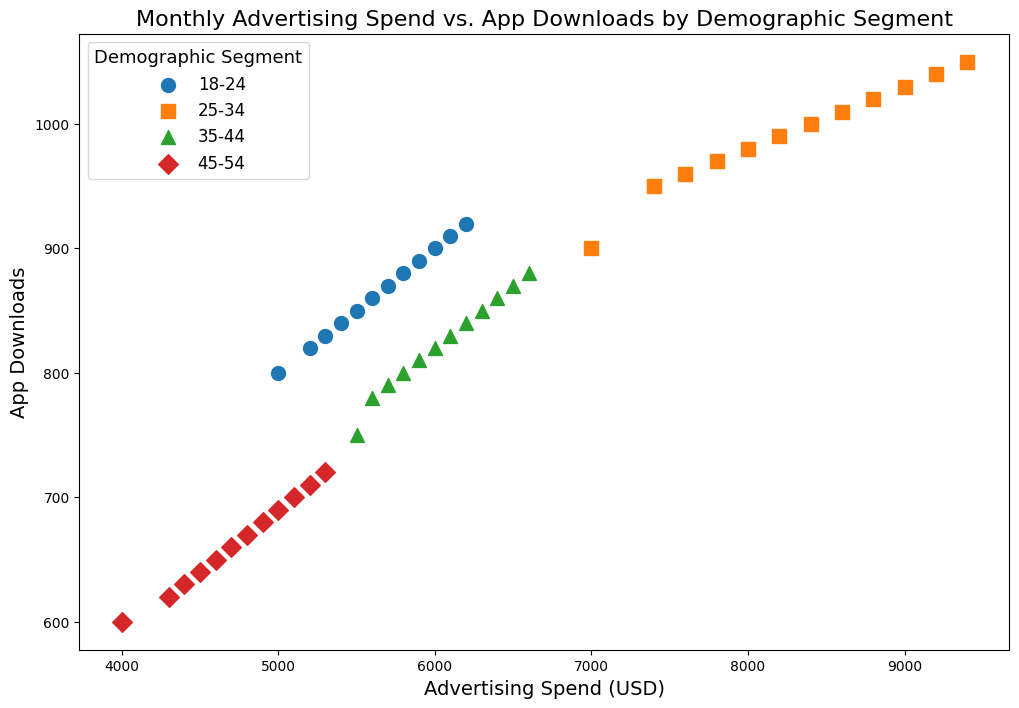What is the demographic segment with the highest app downloads in October 2023? Look at the points corresponding to October 2023 across different demographic segments. The segment '25-34' has the highest value of 1030 app downloads.
Answer: 25-34 Between the '18-24' and '45-54' segments, which had a higher app download rate in December 2023? Compare the app downloads for '18-24' and '45-54' segments in December 2023. The '18-24' segment had 920 downloads, while the '45-54' segment had 720 downloads.
Answer: 18-24 For the '35-44' demographic segment, which month had the highest number of app downloads? Locate the '35-44' segment across all months and identify the month with the highest app downloads. October 2023 had 860 downloads, which is the highest.
Answer: October-2023 During July 2023, which demographic segment had the lowest advertising spend? Examine the points for July 2023 and find the demographic segment with the lowest advertising spend. The '45-54' segment had the lowest spend at 4800 USD.
Answer: 45-54 Calculate the average monthly advertising spend for the '45-54' demographic segment over the year. Sum the advertising spends for '45-54' across all months: 4000 + 4300 + 4400 + 4500 + 4600 + 4700 + 4800 + 4900 + 5000 + 5100 + 5200 + 5300 = 56300 USD. Divide by 12 months: 56300 / 12 = 4691.67 USD.
Answer: 4691.67 Which month is associated with the highest advertising spend for the '25-34' demographic segment, and how many app downloads did it yield? Find the month with the highest advertising spend for '25-34' and note the app downloads. December 2023 had the highest spend at 9400 USD, yielding 1050 downloads.
Answer: December-2023, 1050 downloads What is the overall trend in app downloads for the '25-34' demographic segment over the year? Examine the progression of app downloads for the '25-34' segment from January to December. There is a steady increase in app downloads, starting from 900 in January to 1050 in December.
Answer: Increasing trend Compare the advertising spend of '18-24' and '35-44' segments in June 2023. Which segment spent more, and by how much? Look at the advertising spend for '18-24' and '35-44' in June 2023. '18-24' spent 5600 USD, and '35-44' spent 6000 USD. '35-44' spent 400 USD more.
Answer: 35-44, by 400 USD How does the number of app downloads for the '45-54' segment compare between January 2023 and December 2023? Check the app downloads for '45-54' in January and December. January had 600 downloads, and December had 720 downloads. There is an increase by 120 downloads.
Answer: Increased by 120 